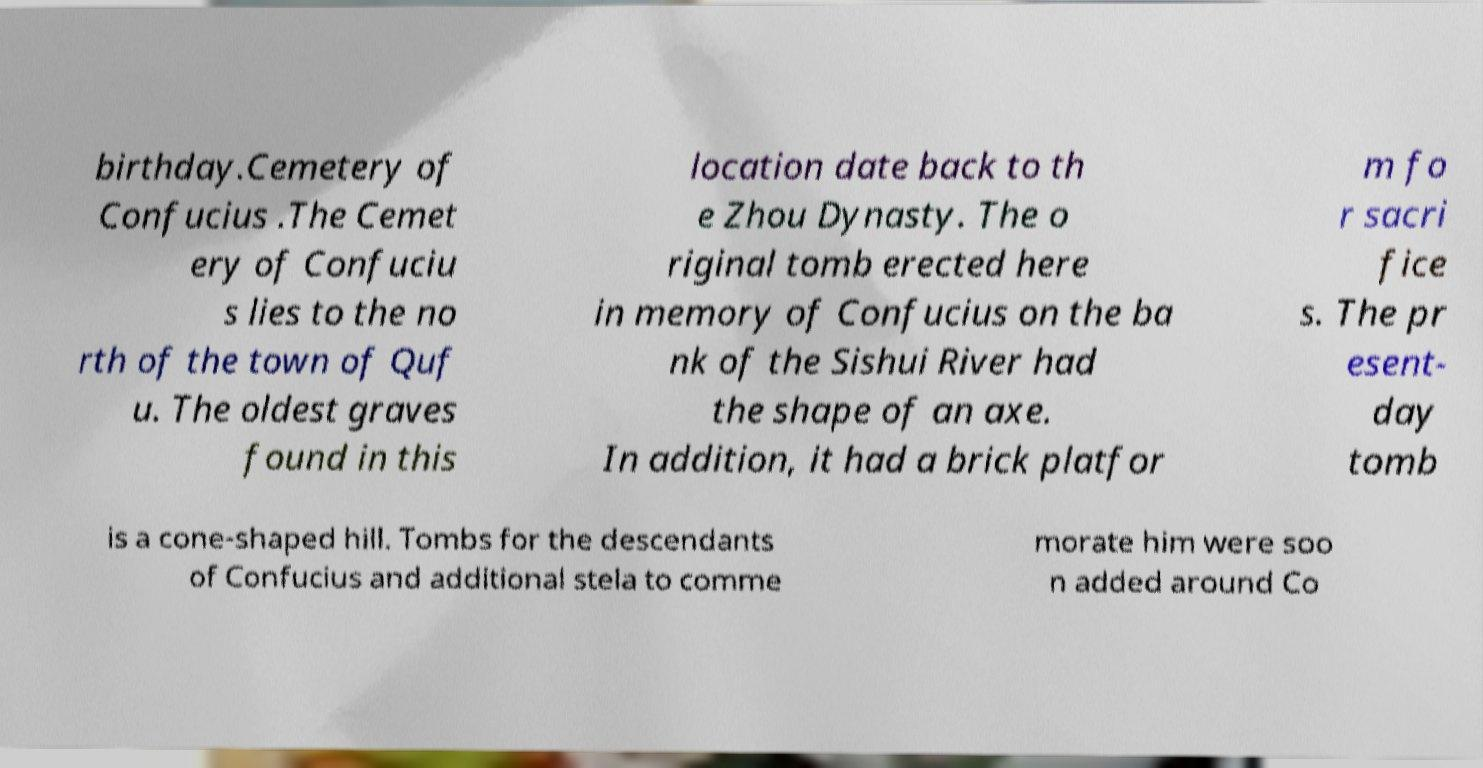Could you assist in decoding the text presented in this image and type it out clearly? birthday.Cemetery of Confucius .The Cemet ery of Confuciu s lies to the no rth of the town of Quf u. The oldest graves found in this location date back to th e Zhou Dynasty. The o riginal tomb erected here in memory of Confucius on the ba nk of the Sishui River had the shape of an axe. In addition, it had a brick platfor m fo r sacri fice s. The pr esent- day tomb is a cone-shaped hill. Tombs for the descendants of Confucius and additional stela to comme morate him were soo n added around Co 